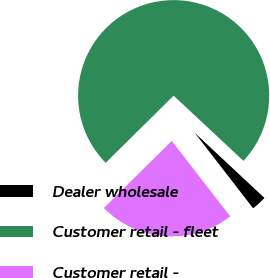Convert chart to OTSL. <chart><loc_0><loc_0><loc_500><loc_500><pie_chart><fcel>Dealer wholesale<fcel>Customer retail - fleet<fcel>Customer retail -<nl><fcel>2.56%<fcel>74.36%<fcel>23.08%<nl></chart> 